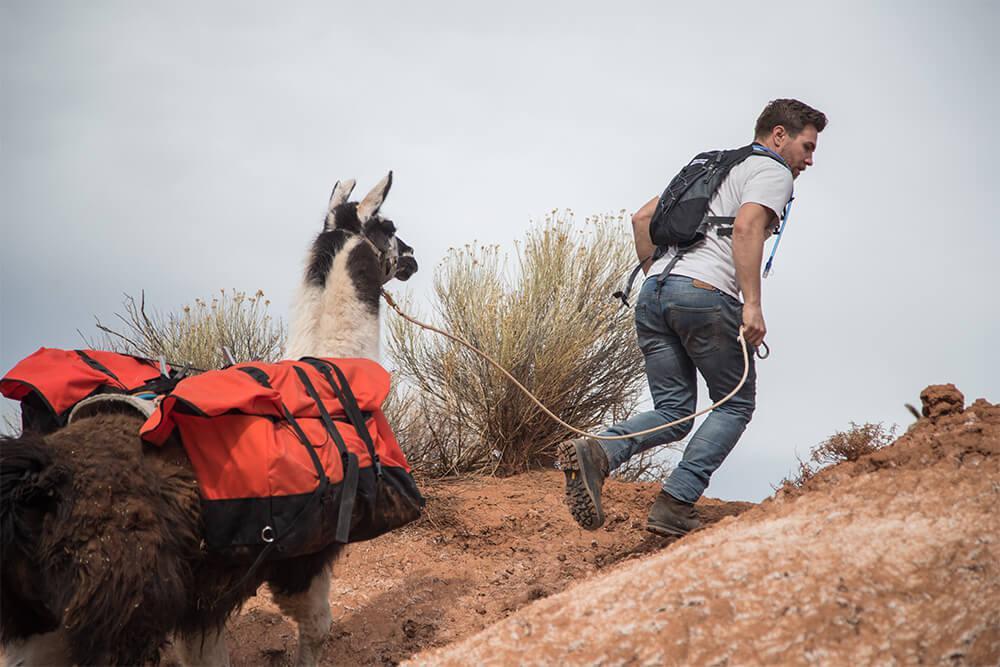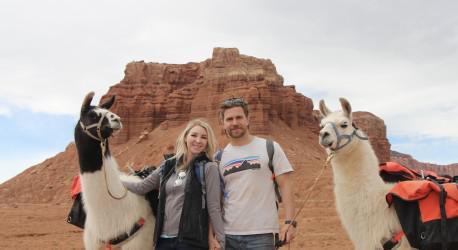The first image is the image on the left, the second image is the image on the right. Analyze the images presented: Is the assertion "A camera-facing man and woman are standing between two pack-wearing llamas and in front of at least one peak." valid? Answer yes or no. Yes. The first image is the image on the left, the second image is the image on the right. Considering the images on both sides, is "Both images contain people and llamas." valid? Answer yes or no. Yes. 